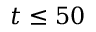<formula> <loc_0><loc_0><loc_500><loc_500>t \leq 5 0</formula> 